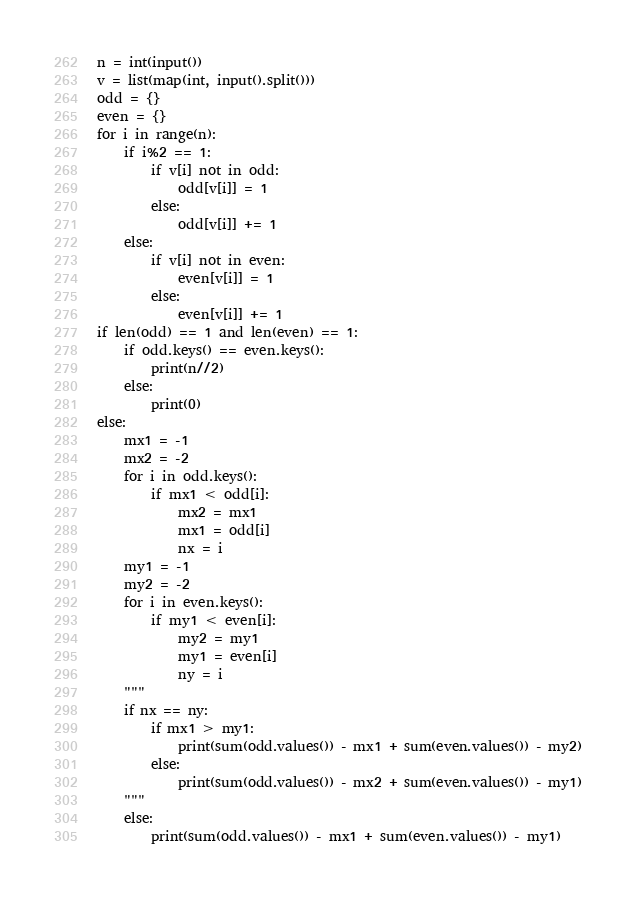<code> <loc_0><loc_0><loc_500><loc_500><_Python_>n = int(input())
v = list(map(int, input().split()))
odd = {}
even = {}
for i in range(n):
    if i%2 == 1:
        if v[i] not in odd:
            odd[v[i]] = 1
        else:
            odd[v[i]] += 1
    else:
        if v[i] not in even:
            even[v[i]] = 1
        else:
            even[v[i]] += 1
if len(odd) == 1 and len(even) == 1:
    if odd.keys() == even.keys():
        print(n//2)
    else:
        print(0)
else:
    mx1 = -1
    mx2 = -2
    for i in odd.keys():
        if mx1 < odd[i]:
            mx2 = mx1
            mx1 = odd[i]
            nx = i
    my1 = -1
    my2 = -2
    for i in even.keys():
        if my1 < even[i]:
            my2 = my1
            my1 = even[i]
            ny = i
    """
    if nx == ny:
        if mx1 > my1:
            print(sum(odd.values()) - mx1 + sum(even.values()) - my2)
        else:
            print(sum(odd.values()) - mx2 + sum(even.values()) - my1)
    """
    else:
        print(sum(odd.values()) - mx1 + sum(even.values()) - my1)</code> 